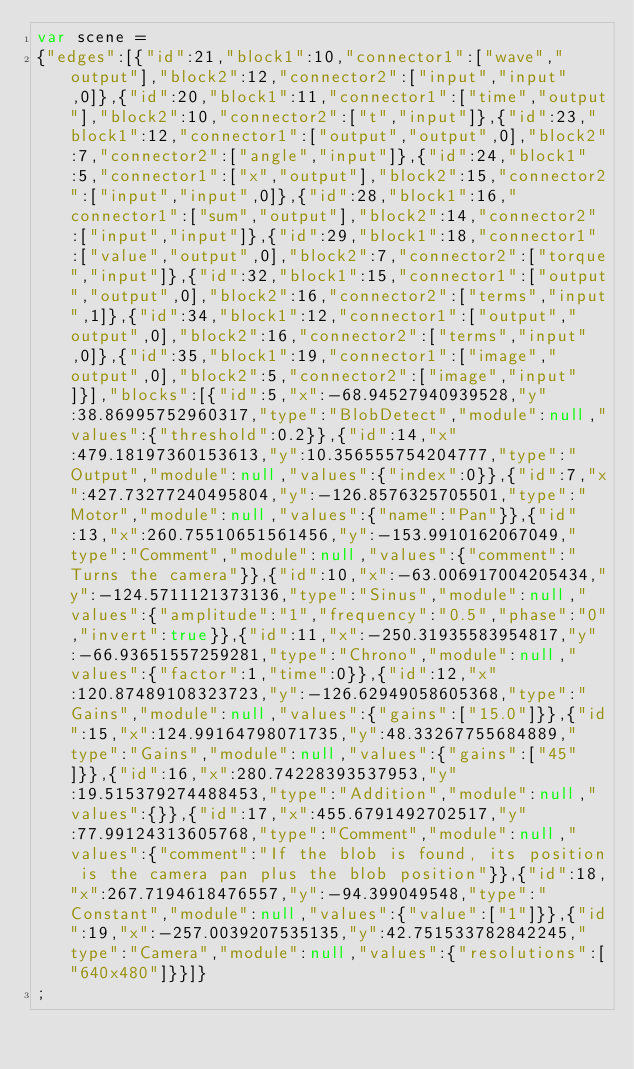Convert code to text. <code><loc_0><loc_0><loc_500><loc_500><_JavaScript_>var scene = 
{"edges":[{"id":21,"block1":10,"connector1":["wave","output"],"block2":12,"connector2":["input","input",0]},{"id":20,"block1":11,"connector1":["time","output"],"block2":10,"connector2":["t","input"]},{"id":23,"block1":12,"connector1":["output","output",0],"block2":7,"connector2":["angle","input"]},{"id":24,"block1":5,"connector1":["x","output"],"block2":15,"connector2":["input","input",0]},{"id":28,"block1":16,"connector1":["sum","output"],"block2":14,"connector2":["input","input"]},{"id":29,"block1":18,"connector1":["value","output",0],"block2":7,"connector2":["torque","input"]},{"id":32,"block1":15,"connector1":["output","output",0],"block2":16,"connector2":["terms","input",1]},{"id":34,"block1":12,"connector1":["output","output",0],"block2":16,"connector2":["terms","input",0]},{"id":35,"block1":19,"connector1":["image","output",0],"block2":5,"connector2":["image","input"]}],"blocks":[{"id":5,"x":-68.94527940939528,"y":38.86995752960317,"type":"BlobDetect","module":null,"values":{"threshold":0.2}},{"id":14,"x":479.18197360153613,"y":10.356555754204777,"type":"Output","module":null,"values":{"index":0}},{"id":7,"x":427.73277240495804,"y":-126.8576325705501,"type":"Motor","module":null,"values":{"name":"Pan"}},{"id":13,"x":260.75510651561456,"y":-153.9910162067049,"type":"Comment","module":null,"values":{"comment":"Turns the camera"}},{"id":10,"x":-63.006917004205434,"y":-124.5711121373136,"type":"Sinus","module":null,"values":{"amplitude":"1","frequency":"0.5","phase":"0","invert":true}},{"id":11,"x":-250.31935583954817,"y":-66.93651557259281,"type":"Chrono","module":null,"values":{"factor":1,"time":0}},{"id":12,"x":120.87489108323723,"y":-126.62949058605368,"type":"Gains","module":null,"values":{"gains":["15.0"]}},{"id":15,"x":124.99164798071735,"y":48.33267755684889,"type":"Gains","module":null,"values":{"gains":["45"]}},{"id":16,"x":280.74228393537953,"y":19.515379274488453,"type":"Addition","module":null,"values":{}},{"id":17,"x":455.6791492702517,"y":77.99124313605768,"type":"Comment","module":null,"values":{"comment":"If the blob is found, its position is the camera pan plus the blob position"}},{"id":18,"x":267.7194618476557,"y":-94.399049548,"type":"Constant","module":null,"values":{"value":["1"]}},{"id":19,"x":-257.0039207535135,"y":42.751533782842245,"type":"Camera","module":null,"values":{"resolutions":["640x480"]}}]}
;
</code> 